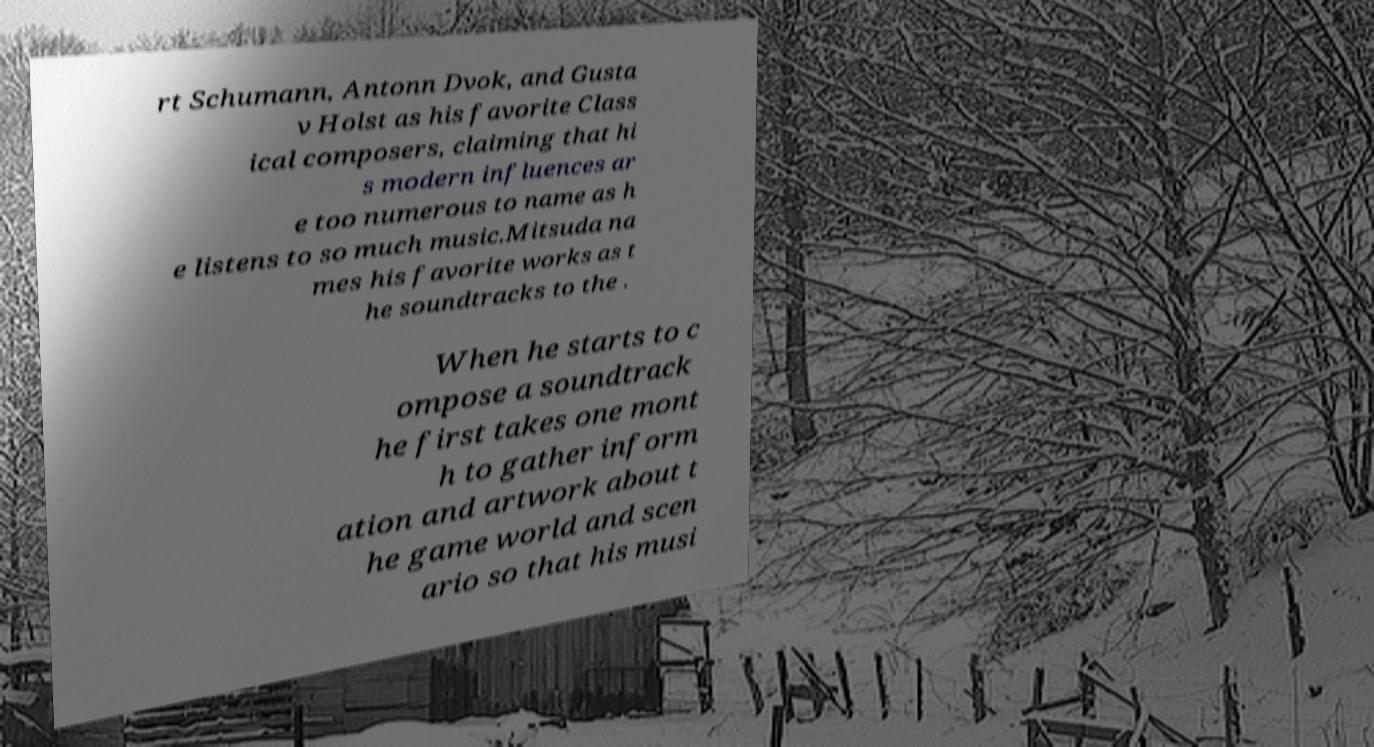Can you accurately transcribe the text from the provided image for me? rt Schumann, Antonn Dvok, and Gusta v Holst as his favorite Class ical composers, claiming that hi s modern influences ar e too numerous to name as h e listens to so much music.Mitsuda na mes his favorite works as t he soundtracks to the . When he starts to c ompose a soundtrack he first takes one mont h to gather inform ation and artwork about t he game world and scen ario so that his musi 